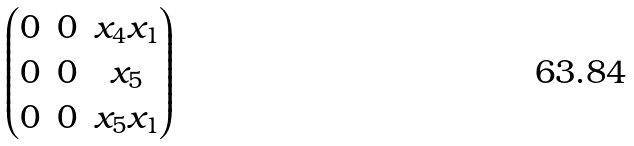<formula> <loc_0><loc_0><loc_500><loc_500>\begin{pmatrix} 0 & 0 & x _ { 4 } x _ { 1 } \\ 0 & 0 & x _ { 5 } \\ 0 & 0 & x _ { 5 } x _ { 1 } \end{pmatrix}</formula> 